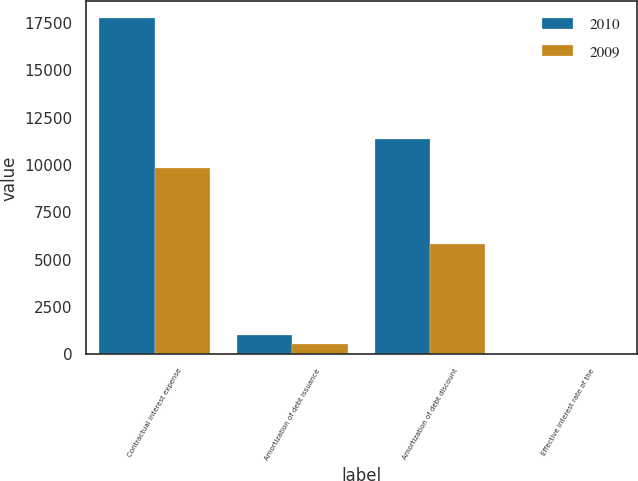<chart> <loc_0><loc_0><loc_500><loc_500><stacked_bar_chart><ecel><fcel>Contractual interest expense<fcel>Amortization of debt issuance<fcel>Amortization of debt discount<fcel>Effective interest rate of the<nl><fcel>2010<fcel>17753<fcel>1033<fcel>11390<fcel>10.88<nl><fcel>2009<fcel>9814<fcel>573<fcel>5820<fcel>10.88<nl></chart> 